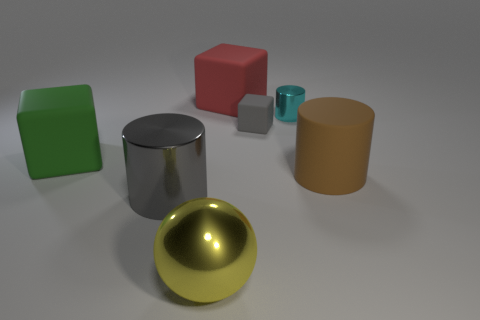There is a metal ball; is it the same size as the metallic cylinder that is on the right side of the large yellow object?
Provide a short and direct response. No. Is the number of big rubber cylinders to the left of the big gray metal cylinder greater than the number of blue matte objects?
Give a very brief answer. No. How many gray cylinders are the same size as the brown thing?
Provide a succinct answer. 1. Do the matte object behind the cyan metallic cylinder and the matte cylinder in front of the tiny shiny cylinder have the same size?
Provide a short and direct response. Yes. Is the number of yellow metal spheres that are on the left side of the big yellow thing greater than the number of large metal things that are right of the tiny cyan metal thing?
Make the answer very short. No. What number of other large yellow metallic objects are the same shape as the big yellow thing?
Your response must be concise. 0. There is a brown cylinder that is the same size as the green rubber thing; what is its material?
Ensure brevity in your answer.  Rubber. Are there any big cubes made of the same material as the big gray cylinder?
Offer a very short reply. No. Is the number of large matte things that are in front of the large red matte object less than the number of tiny cylinders?
Your answer should be very brief. No. There is a small thing that is in front of the metal cylinder to the right of the yellow shiny sphere; what is it made of?
Provide a succinct answer. Rubber. 